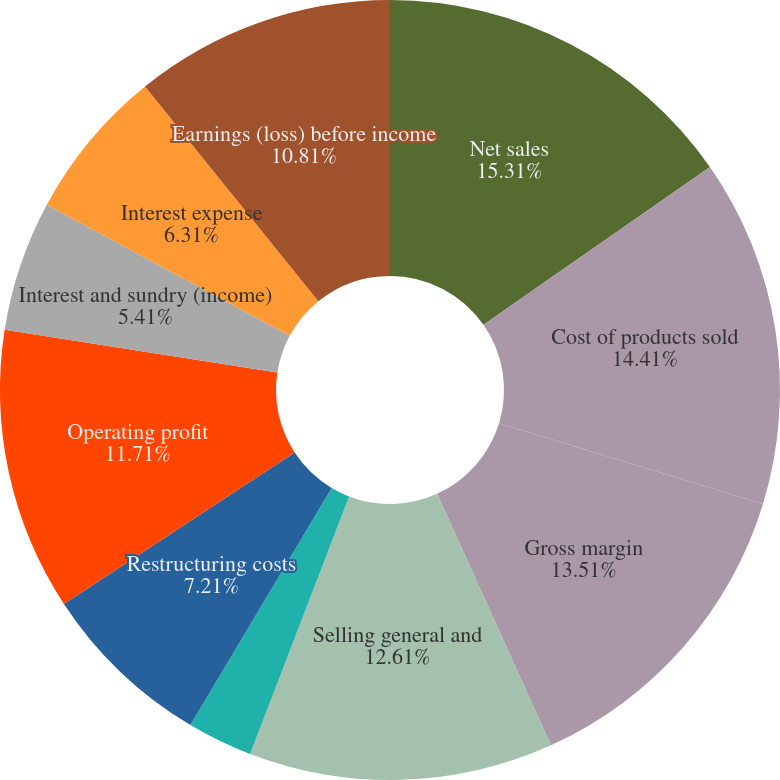Convert chart to OTSL. <chart><loc_0><loc_0><loc_500><loc_500><pie_chart><fcel>Net sales<fcel>Cost of products sold<fcel>Gross margin<fcel>Selling general and<fcel>Intangible amortization<fcel>Restructuring costs<fcel>Operating profit<fcel>Interest and sundry (income)<fcel>Interest expense<fcel>Earnings (loss) before income<nl><fcel>15.31%<fcel>14.41%<fcel>13.51%<fcel>12.61%<fcel>2.71%<fcel>7.21%<fcel>11.71%<fcel>5.41%<fcel>6.31%<fcel>10.81%<nl></chart> 